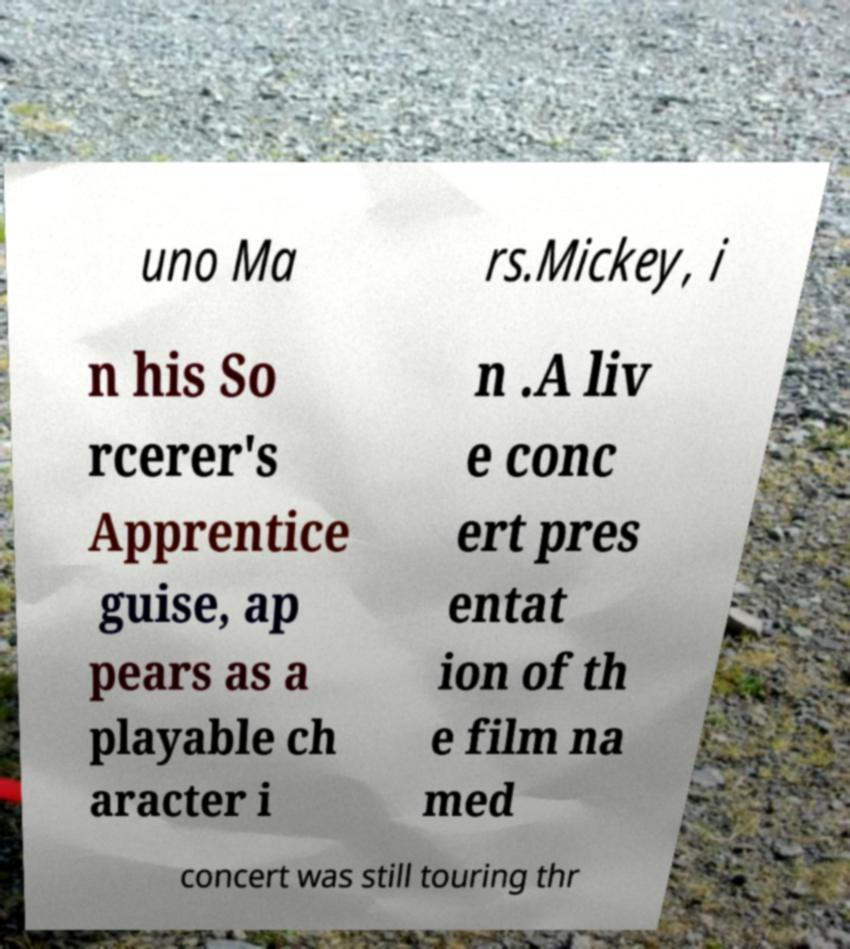Please identify and transcribe the text found in this image. uno Ma rs.Mickey, i n his So rcerer's Apprentice guise, ap pears as a playable ch aracter i n .A liv e conc ert pres entat ion of th e film na med concert was still touring thr 